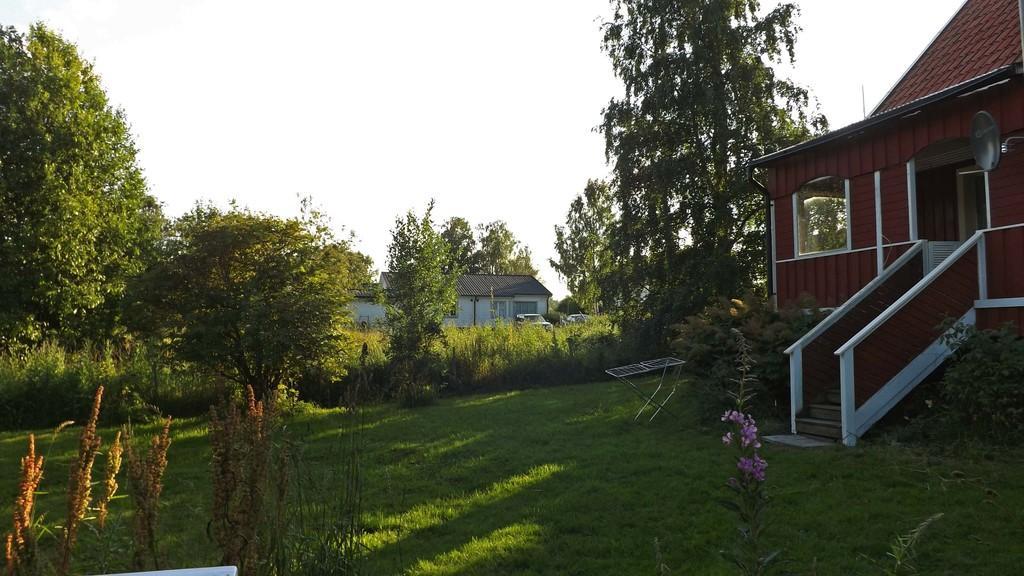Describe this image in one or two sentences. In this image in the middle, there are trees, plants, grass, houses, staircase, flowers, window and sky. 